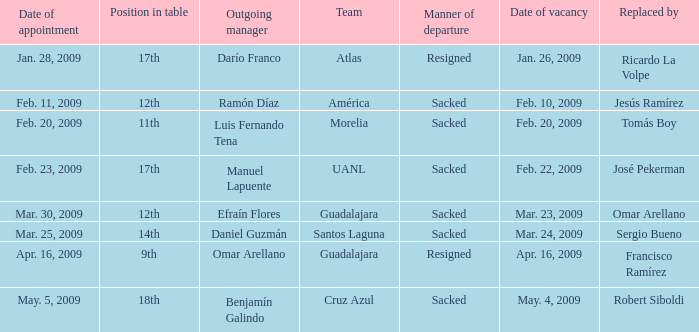What is Position in Table, when Replaced By is "Sergio Bueno"? 14th. 